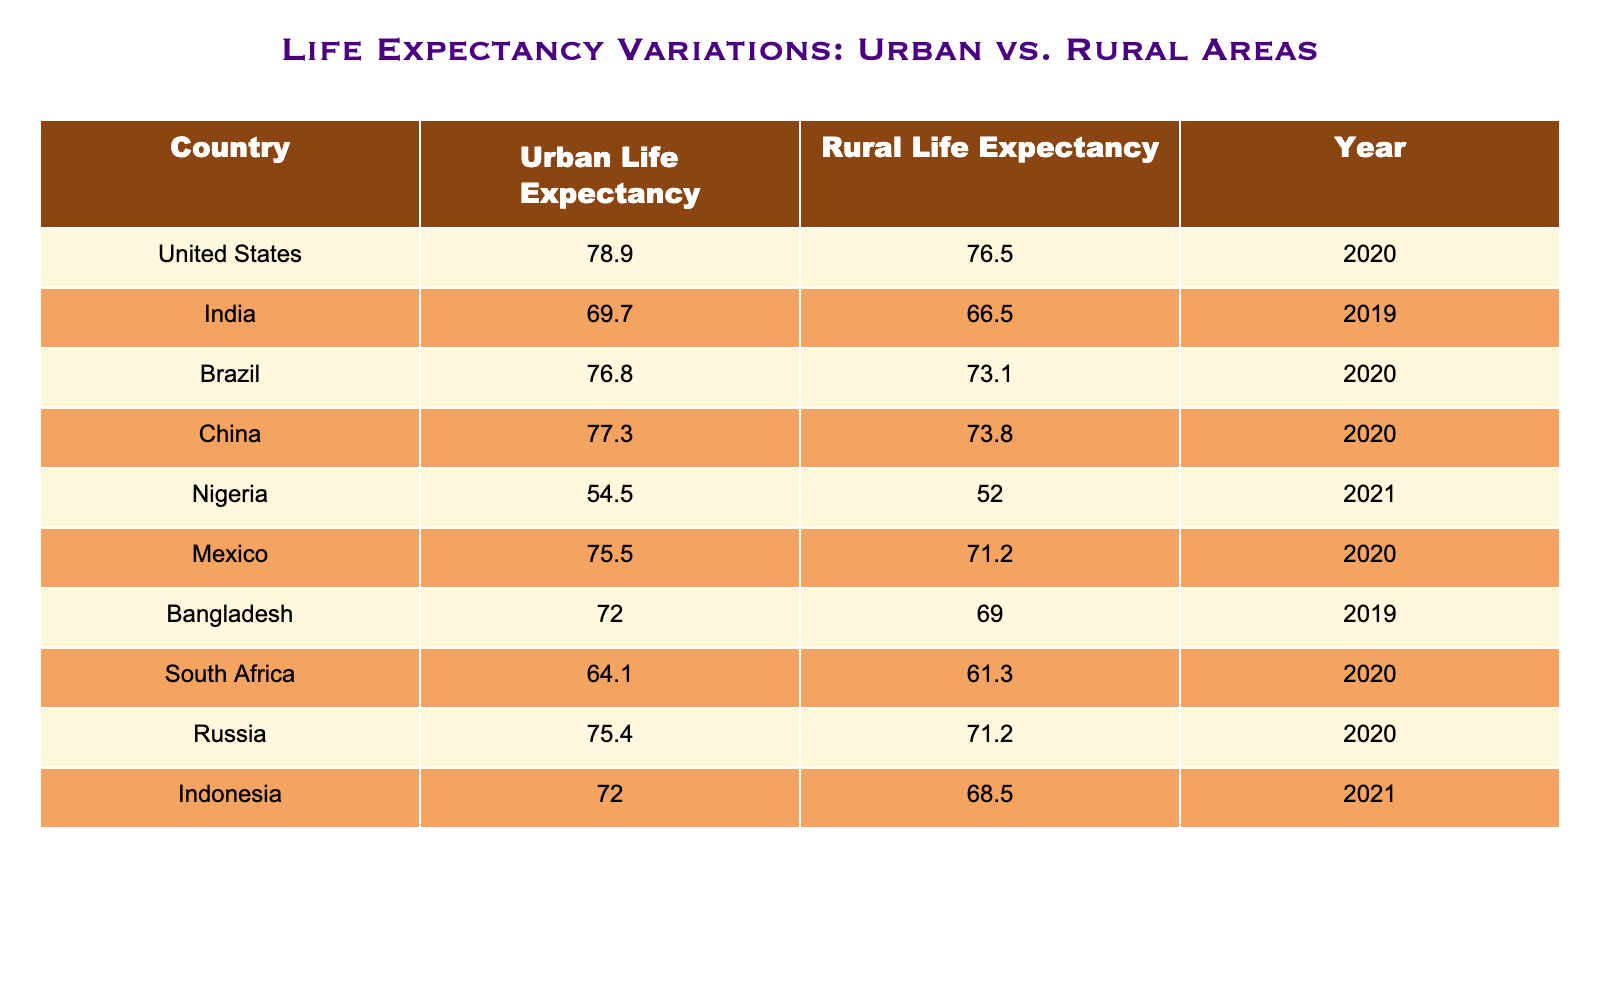What is the urban life expectancy for the United States? The table directly provides the value for urban life expectancy in the United States, which is listed under the "Urban Life Expectancy" column for that country.
Answer: 78.9 What country has the highest rural life expectancy? By comparing the values in the "Rural Life Expectancy" column, it can be seen that Russia has the highest value of 71.2.
Answer: Russia Is life expectancy higher in urban or rural areas for Nigeria? By comparing the urban life expectancy of Nigeria (54.5) to the rural life expectancy (52.0), it shows that urban life expectancy is higher.
Answer: Yes What is the difference between urban and rural life expectancy in Brazil? The urban life expectancy in Brazil is 76.8, while the rural life expectancy is 73.1. The difference can be calculated as 76.8 - 73.1 = 3.7.
Answer: 3.7 Which country has the largest gap between urban and rural life expectancy? To determine the largest gap, we need to calculate the difference for each country: United States (2.4), India (3.2), Brazil (3.7), China (3.5), Nigeria (2.5), Mexico (4.3), Bangladesh (3.0), South Africa (2.8), Russia (4.2), and Indonesia (3.5). The largest gap is found in Mexico with a difference of 4.3.
Answer: Mexico What is the average urban life expectancy across all listed countries? We take the urban life expectancies (78.9, 69.7, 76.8, 77.3, 54.5, 75.5, 72.0, 64.1, 75.4, 72.0) and calculate the average by summing them (78.9 + 69.7 + 76.8 + 77.3 + 54.5 + 75.5 + 72.0 + 64.1 + 75.4 + 72.0 = 745.2), and then divide by the total number of countries (10): 745.2 / 10 = 74.52.
Answer: 74.52 Is South Africa's urban life expectancy above or below the average for urban areas? Having previously calculated the average urban life expectancy as 74.52, we compare this with South Africa's urban life expectancy, which is 64.1. Since 64.1 is less than the average, the answer is no.
Answer: No Which country has a rural life expectancy less than 70? By scanning the "Rural Life Expectancy" column, we see that India (66.5), Nigeria (52.0), and Bangladesh (69.0) all have rural life expectancies under 70.
Answer: India, Nigeria, Bangladesh 